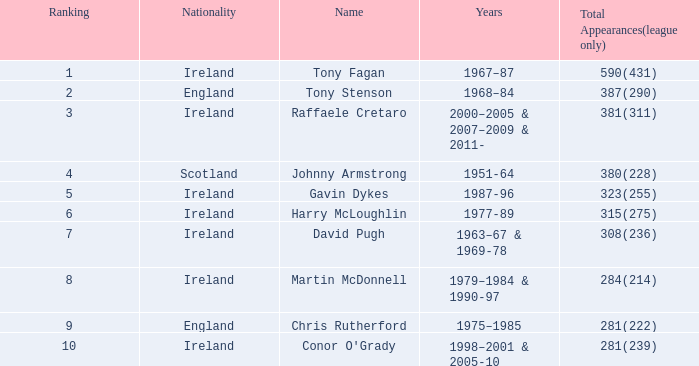How many total appearances (league only) have a name of gavin dykes? 323(255). 